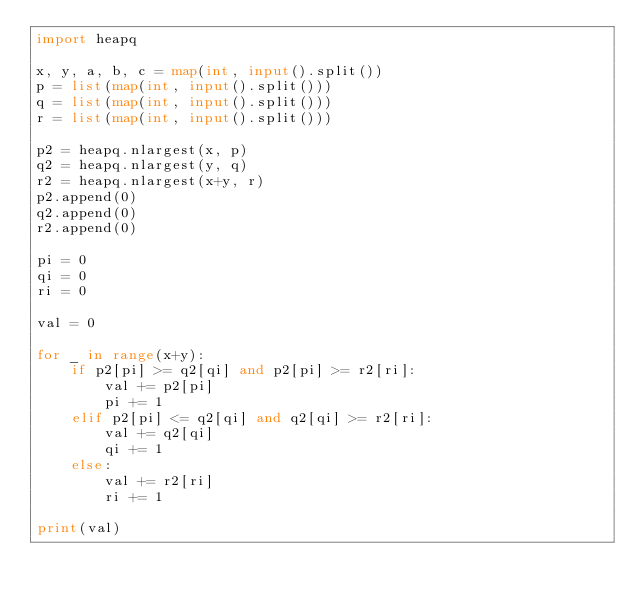<code> <loc_0><loc_0><loc_500><loc_500><_Python_>import heapq

x, y, a, b, c = map(int, input().split())
p = list(map(int, input().split()))
q = list(map(int, input().split()))
r = list(map(int, input().split()))

p2 = heapq.nlargest(x, p)
q2 = heapq.nlargest(y, q)
r2 = heapq.nlargest(x+y, r)
p2.append(0)
q2.append(0)
r2.append(0)

pi = 0
qi = 0
ri = 0

val = 0

for _ in range(x+y):
    if p2[pi] >= q2[qi] and p2[pi] >= r2[ri]:
        val += p2[pi]
        pi += 1
    elif p2[pi] <= q2[qi] and q2[qi] >= r2[ri]:
        val += q2[qi]
        qi += 1
    else:
        val += r2[ri]
        ri += 1

print(val)
</code> 